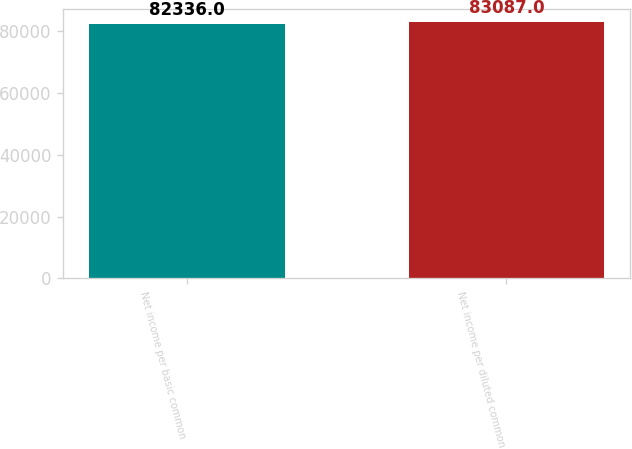Convert chart to OTSL. <chart><loc_0><loc_0><loc_500><loc_500><bar_chart><fcel>Net income per basic common<fcel>Net income per diluted common<nl><fcel>82336<fcel>83087<nl></chart> 